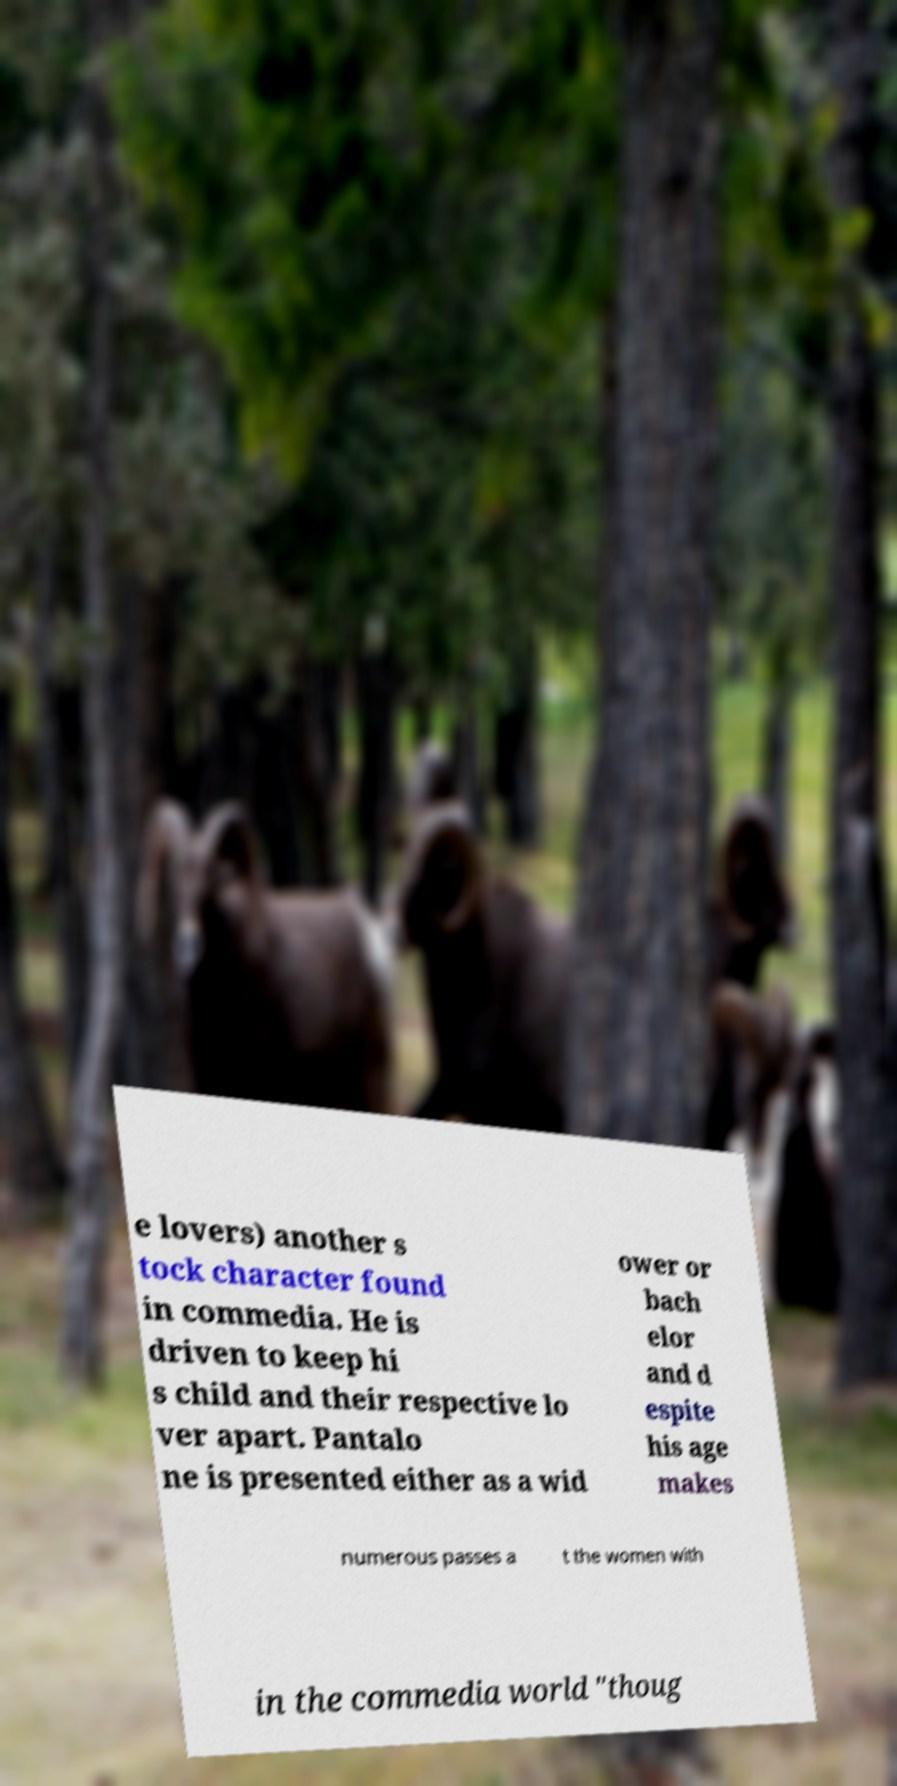Could you extract and type out the text from this image? e lovers) another s tock character found in commedia. He is driven to keep hi s child and their respective lo ver apart. Pantalo ne is presented either as a wid ower or bach elor and d espite his age makes numerous passes a t the women with in the commedia world "thoug 